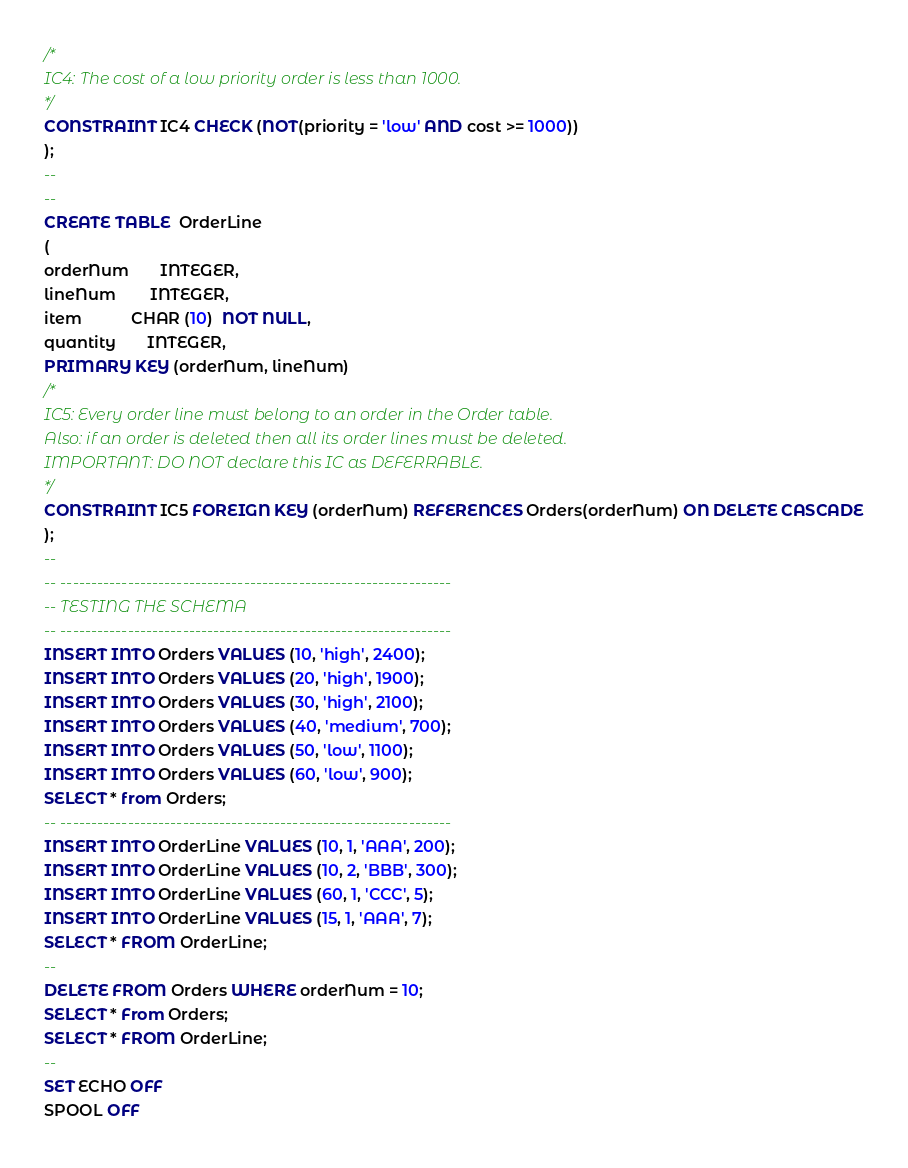Convert code to text. <code><loc_0><loc_0><loc_500><loc_500><_SQL_>/* 
IC4: The cost of a low priority order is less than 1000. 
*/ 
CONSTRAINT IC4 CHECK (NOT(priority = 'low' AND cost >= 1000))
); 
-- 
-- 
CREATE TABLE  OrderLine 
( 
orderNum       INTEGER, 
lineNum        INTEGER, 
item           CHAR (10)  NOT NULL, 
quantity       INTEGER, 
PRIMARY KEY (orderNum, lineNum)
/* 
IC5: Every order line must belong to an order in the Order table.  
Also: if an order is deleted then all its order lines must be deleted. 
IMPORTANT: DO NOT declare this IC as DEFERRABLE. 
*/ 
CONSTRAINT IC5 FOREIGN KEY (orderNum) REFERENCES Orders(orderNum) ON DELETE CASCADE
); 
-- 
-- ---------------------------------------------------------------- 
-- TESTING THE SCHEMA 
-- ---------------------------------------------------------------- 
INSERT INTO Orders VALUES (10, 'high', 2400); 
INSERT INTO Orders VALUES (20, 'high', 1900); 
INSERT INTO Orders VALUES (30, 'high', 2100); 
INSERT INTO Orders VALUES (40, 'medium', 700); 
INSERT INTO Orders VALUES (50, 'low', 1100); 
INSERT INTO Orders VALUES (60, 'low', 900); 
SELECT * from Orders; 
-- ---------------------------------------------------------------- 
INSERT INTO OrderLine VALUES (10, 1, 'AAA', 200); 
INSERT INTO OrderLine VALUES (10, 2, 'BBB', 300); 
INSERT INTO OrderLine VALUES (60, 1, 'CCC', 5); 
INSERT INTO OrderLine VALUES (15, 1, 'AAA', 7); 
SELECT * FROM OrderLine; 
-- 
DELETE FROM Orders WHERE orderNum = 10; 
SELECT * From Orders; 
SELECT * FROM OrderLine; 
-- 
SET ECHO OFF 
SPOOL OFF 
</code> 